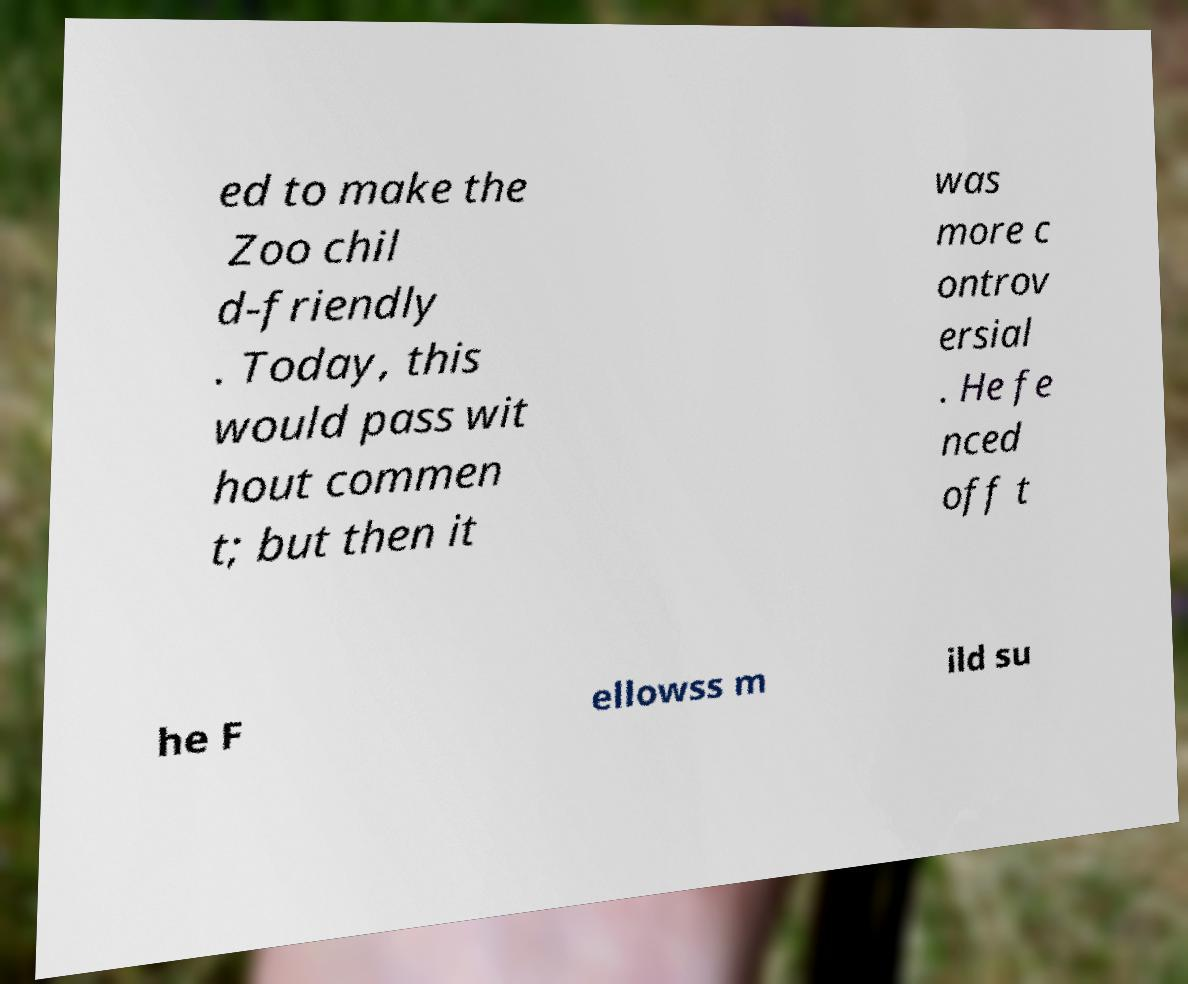For documentation purposes, I need the text within this image transcribed. Could you provide that? ed to make the Zoo chil d-friendly . Today, this would pass wit hout commen t; but then it was more c ontrov ersial . He fe nced off t he F ellowss m ild su 